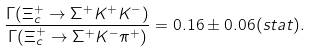Convert formula to latex. <formula><loc_0><loc_0><loc_500><loc_500>\frac { \Gamma ( \Xi _ { c } ^ { + } \rightarrow \Sigma ^ { + } K ^ { + } K ^ { - } ) } { \Gamma ( \Xi _ { c } ^ { + } \rightarrow \Sigma ^ { + } K ^ { - } \pi ^ { + } ) } = 0 . 1 6 \pm 0 . 0 6 ( s t a t ) .</formula> 